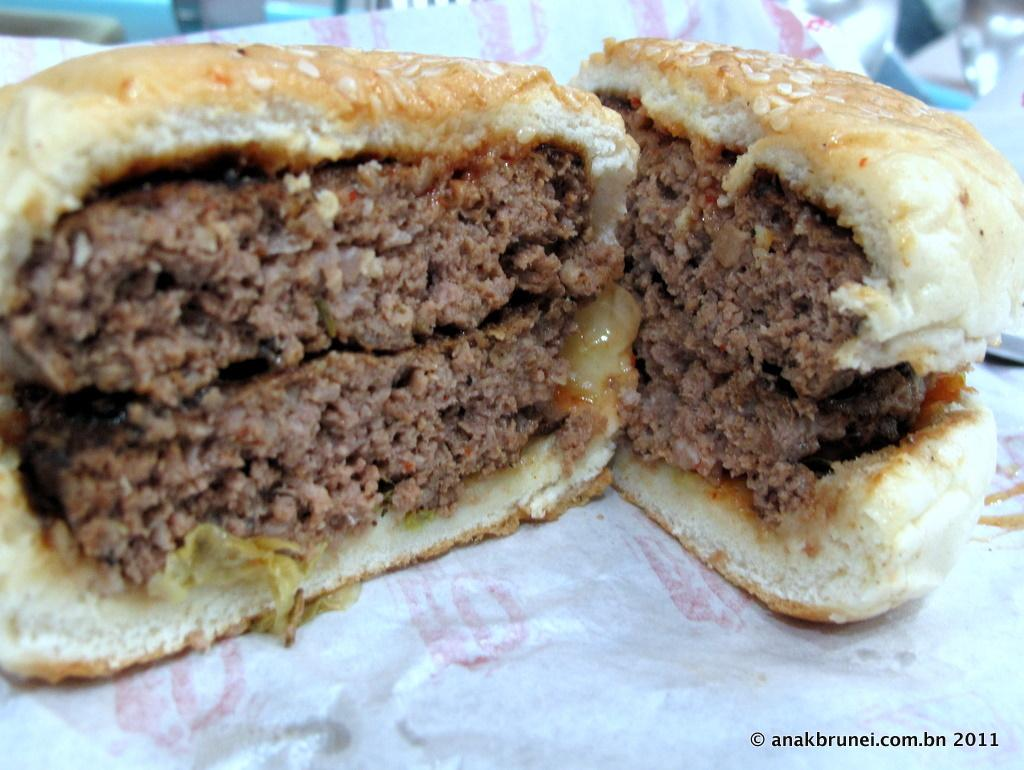What can be seen in the image related to food? There is food visible in the image. What type of vegetable is being used by the team in the image? There is no vegetable or team present in the image; it only shows food. 